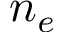<formula> <loc_0><loc_0><loc_500><loc_500>n _ { e }</formula> 